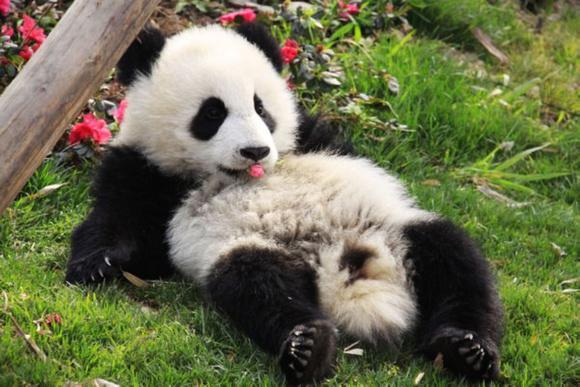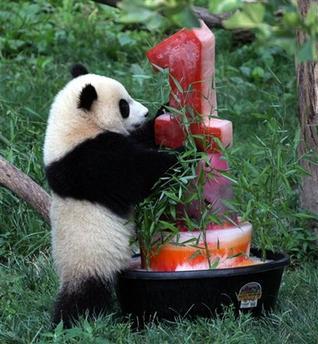The first image is the image on the left, the second image is the image on the right. Given the left and right images, does the statement "The left and right image contains the same number of pandas." hold true? Answer yes or no. Yes. The first image is the image on the left, the second image is the image on the right. For the images displayed, is the sentence "A panda is laying on its back." factually correct? Answer yes or no. Yes. 